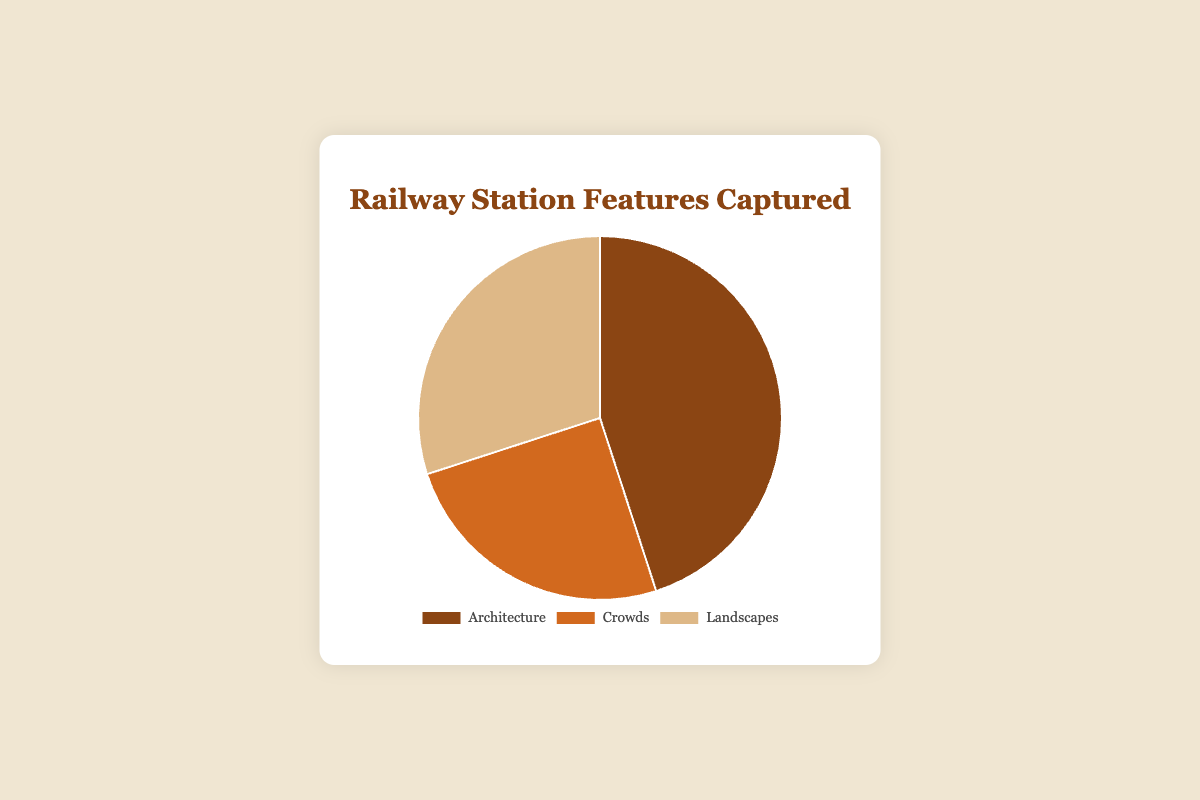Which feature has the highest percentage? The feature with the highest percentage is represented by the largest slice in the pie chart. In this case, Architecture has the largest slice.
Answer: Architecture Which feature has the lowest percentage? The feature with the lowest percentage is represented by the smallest slice in the pie chart. In this case, Crowds has the smallest slice.
Answer: Crowds What is the combined percentage of Crowds and Landscapes? Add the percentages of Crowds and Landscapes. Crowds is 25% and Landscapes is 30%. So, 25% + 30% = 55%.
Answer: 55% How much bigger is the percentage of Architecture compared to Crowds? Subtract the percentage of Crowds from Architecture. Architecture is 45% and Crowds is 25%. So, 45% - 25% = 20%.
Answer: 20% Which two features together make up more than half of the total percentage? Add the percentages of different pairs of features to see which pair adds up to more than 50%. Architecture (45%) + Landscapes (30%) = 75%.
Answer: Architecture and Landscapes What percentage of features is not related to Architecture? Subtract the percentage of Architecture from 100%. 100% - 45% = 55%.
Answer: 55% Which feature has the second largest percentage? The second largest slice in the pie chart represents the feature with the second largest percentage. In this case, Landscapes has the second largest slice.
Answer: Landscapes What is the difference in percentage between the largest and smallest features? Subtract the smallest percentage from the largest. Architecture is 45% and Crowds is 25%. So, 45% - 25% = 20%.
Answer: 20% What is the average percentage of all features? Add all the percentages together and divide by the number of features. (45% + 25% + 30%) / 3 = 100% / 3 ≈ 33.33%.
Answer: 33.33% If you captured 200 photos, how many photos feature Crowds? Multiply the total number of photos by the percentage of Crowds. 200 photos * 25% = 50 photos.
Answer: 50 